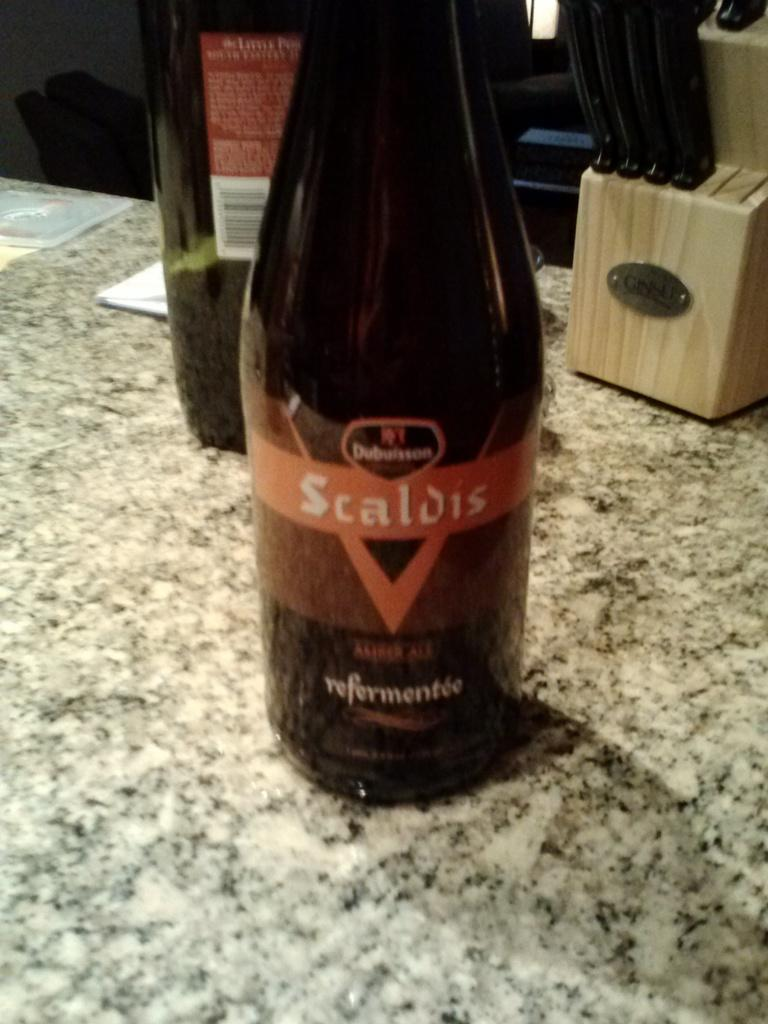What object can be seen in the image? There is a bottle in the image. What is located behind the bottle? There is a knife stand behind the bottle. How many knives are in the knife stand? The knife stand has four knives. What type of authority figure can be seen in the image? There is no authority figure present in the image. Is there a cave visible in the image? There is no cave present in the image. 